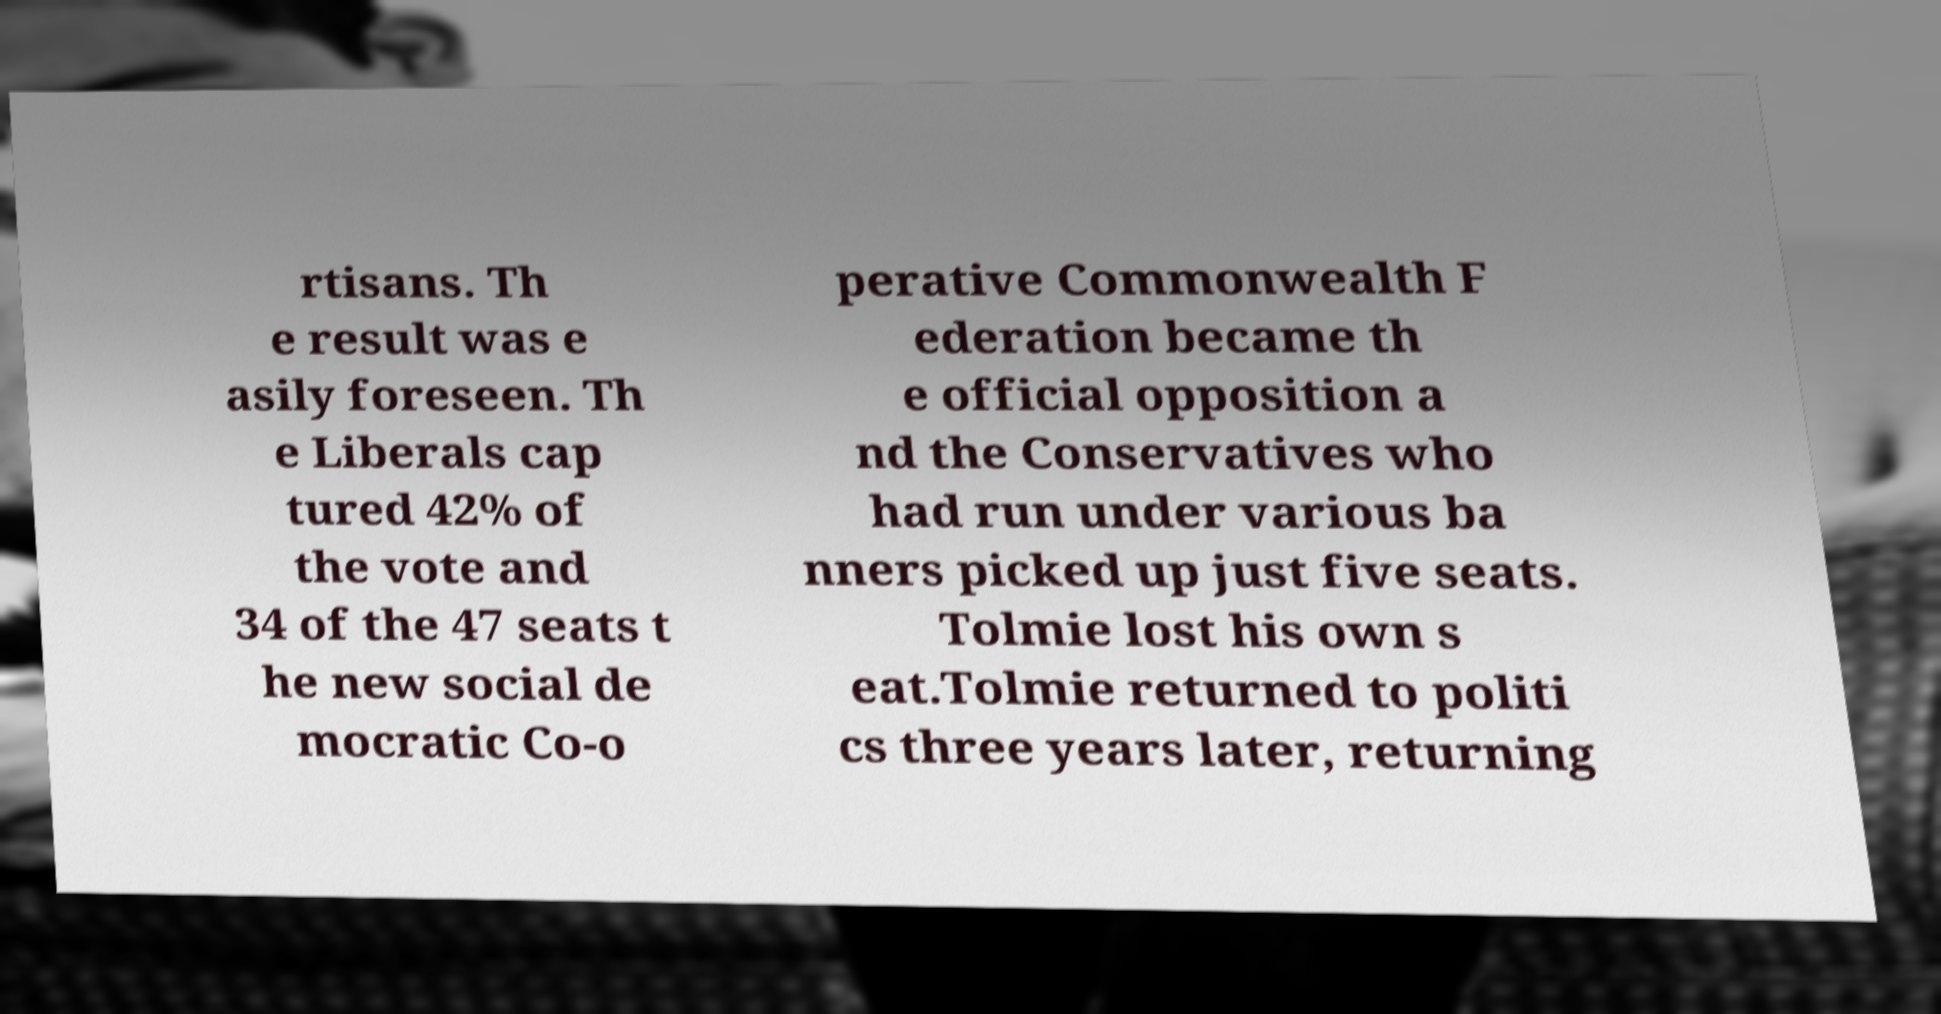There's text embedded in this image that I need extracted. Can you transcribe it verbatim? rtisans. Th e result was e asily foreseen. Th e Liberals cap tured 42% of the vote and 34 of the 47 seats t he new social de mocratic Co-o perative Commonwealth F ederation became th e official opposition a nd the Conservatives who had run under various ba nners picked up just five seats. Tolmie lost his own s eat.Tolmie returned to politi cs three years later, returning 